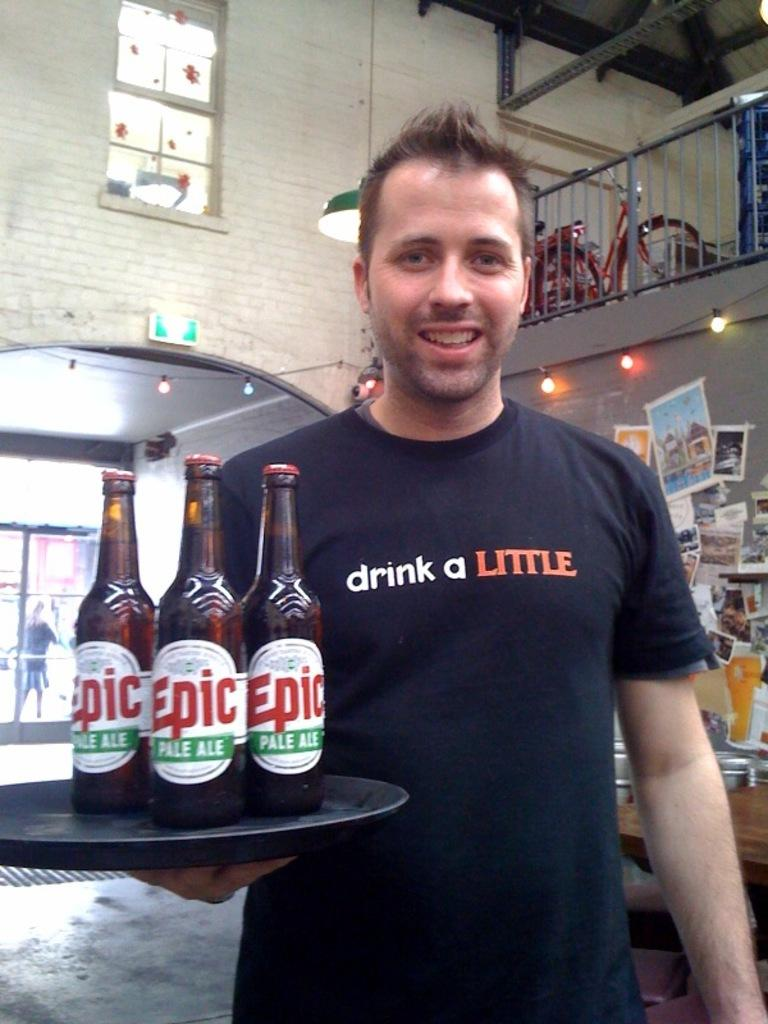<image>
Present a compact description of the photo's key features. A man in a shirt that says Drink a Little holds a tray of ale. 